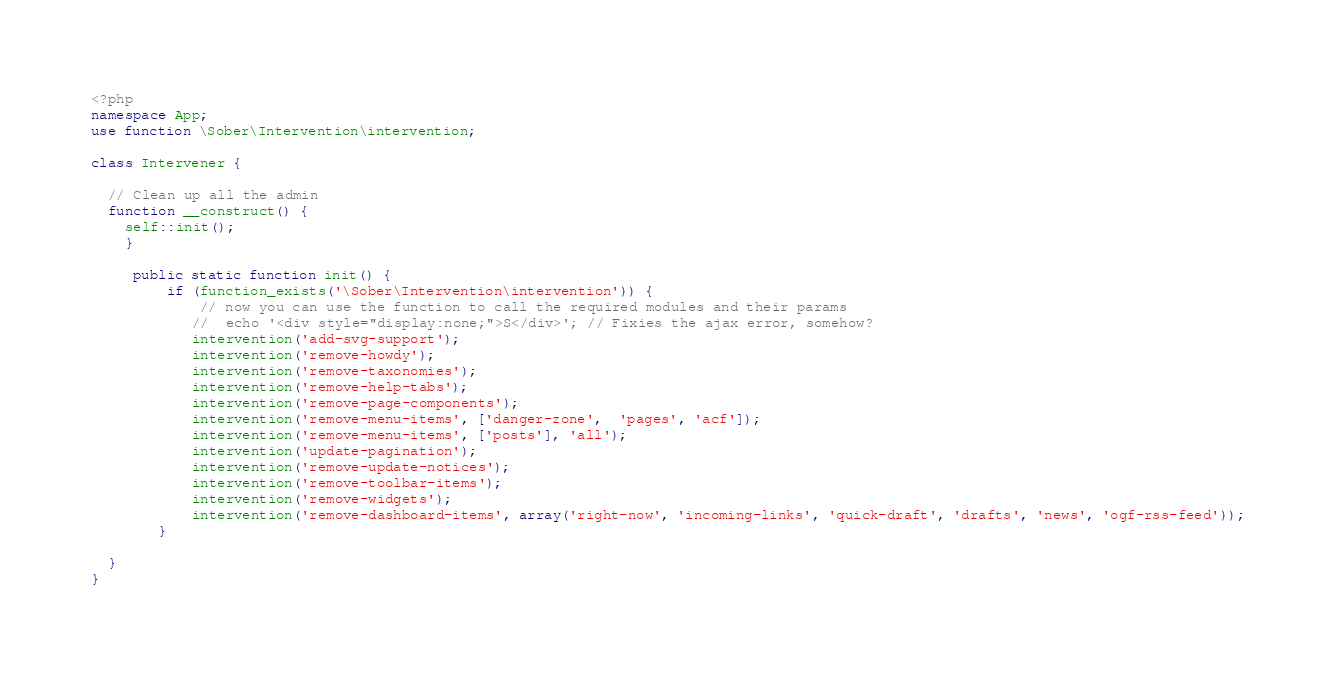<code> <loc_0><loc_0><loc_500><loc_500><_PHP_><?php
namespace App;
use function \Sober\Intervention\intervention;

class Intervener {

  // Clean up all the admin
  function __construct() {
    self::init();
	}

	 public static function init() {
		 if (function_exists('\Sober\Intervention\intervention')) {
			 // now you can use the function to call the required modules and their params
			//  echo '<div style="display:none;">S</div>'; // Fixies the ajax error, somehow?
			intervention('add-svg-support');
			intervention('remove-howdy');
			intervention('remove-taxonomies');
			intervention('remove-help-tabs');
			intervention('remove-page-components');
			intervention('remove-menu-items', ['danger-zone',  'pages', 'acf']);
			intervention('remove-menu-items', ['posts'], 'all');
			intervention('update-pagination');
			intervention('remove-update-notices');
			intervention('remove-toolbar-items');
			intervention('remove-widgets');
			intervention('remove-dashboard-items', array('right-now', 'incoming-links', 'quick-draft', 'drafts', 'news', 'ogf-rss-feed'));
		}

  }
}</code> 